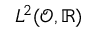<formula> <loc_0><loc_0><loc_500><loc_500>L ^ { 2 } ( \mathcal { O } , \mathbb { R } )</formula> 